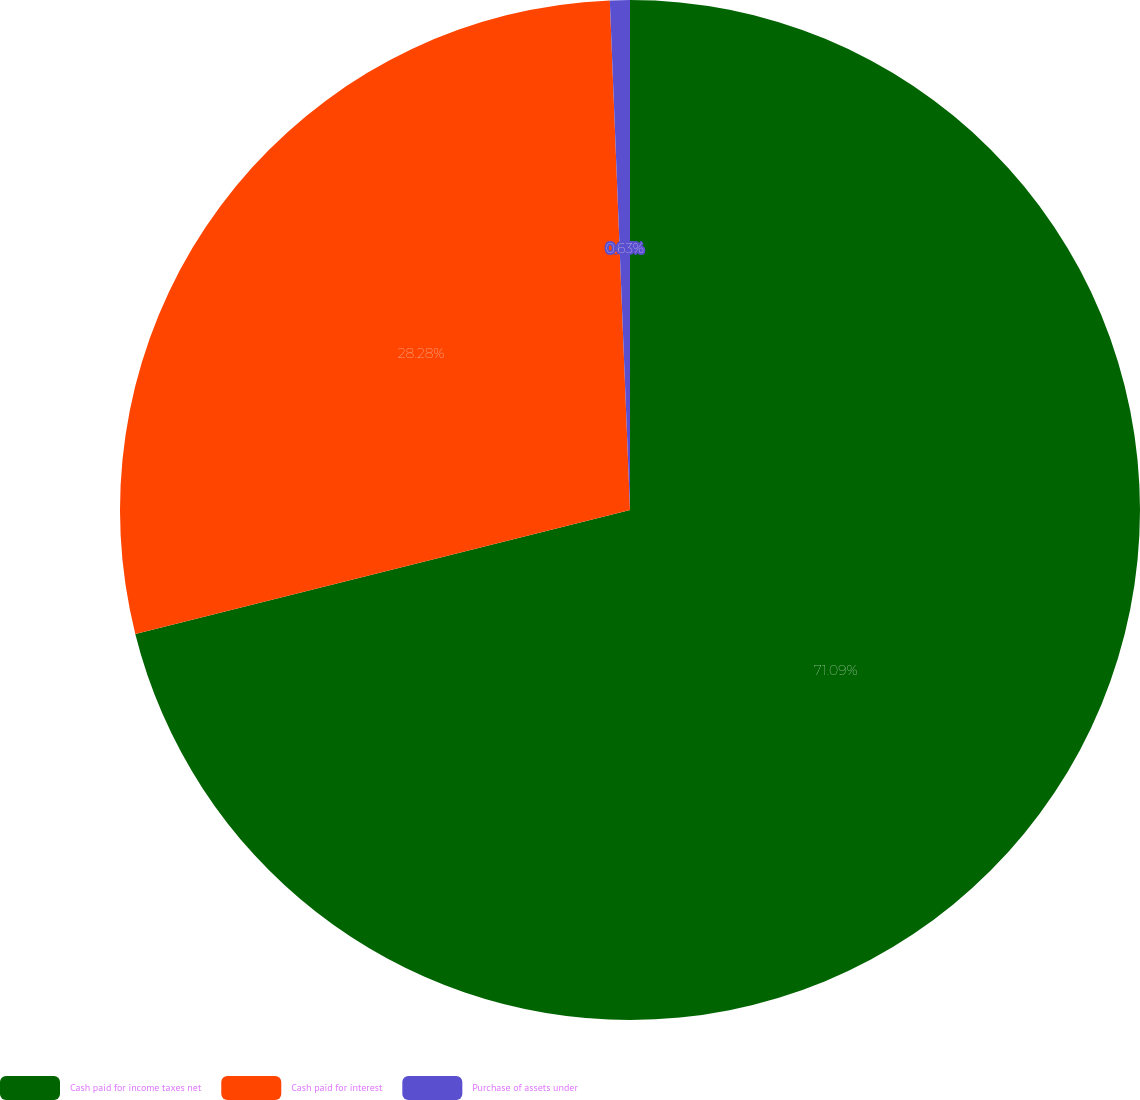Convert chart to OTSL. <chart><loc_0><loc_0><loc_500><loc_500><pie_chart><fcel>Cash paid for income taxes net<fcel>Cash paid for interest<fcel>Purchase of assets under<nl><fcel>71.1%<fcel>28.28%<fcel>0.63%<nl></chart> 